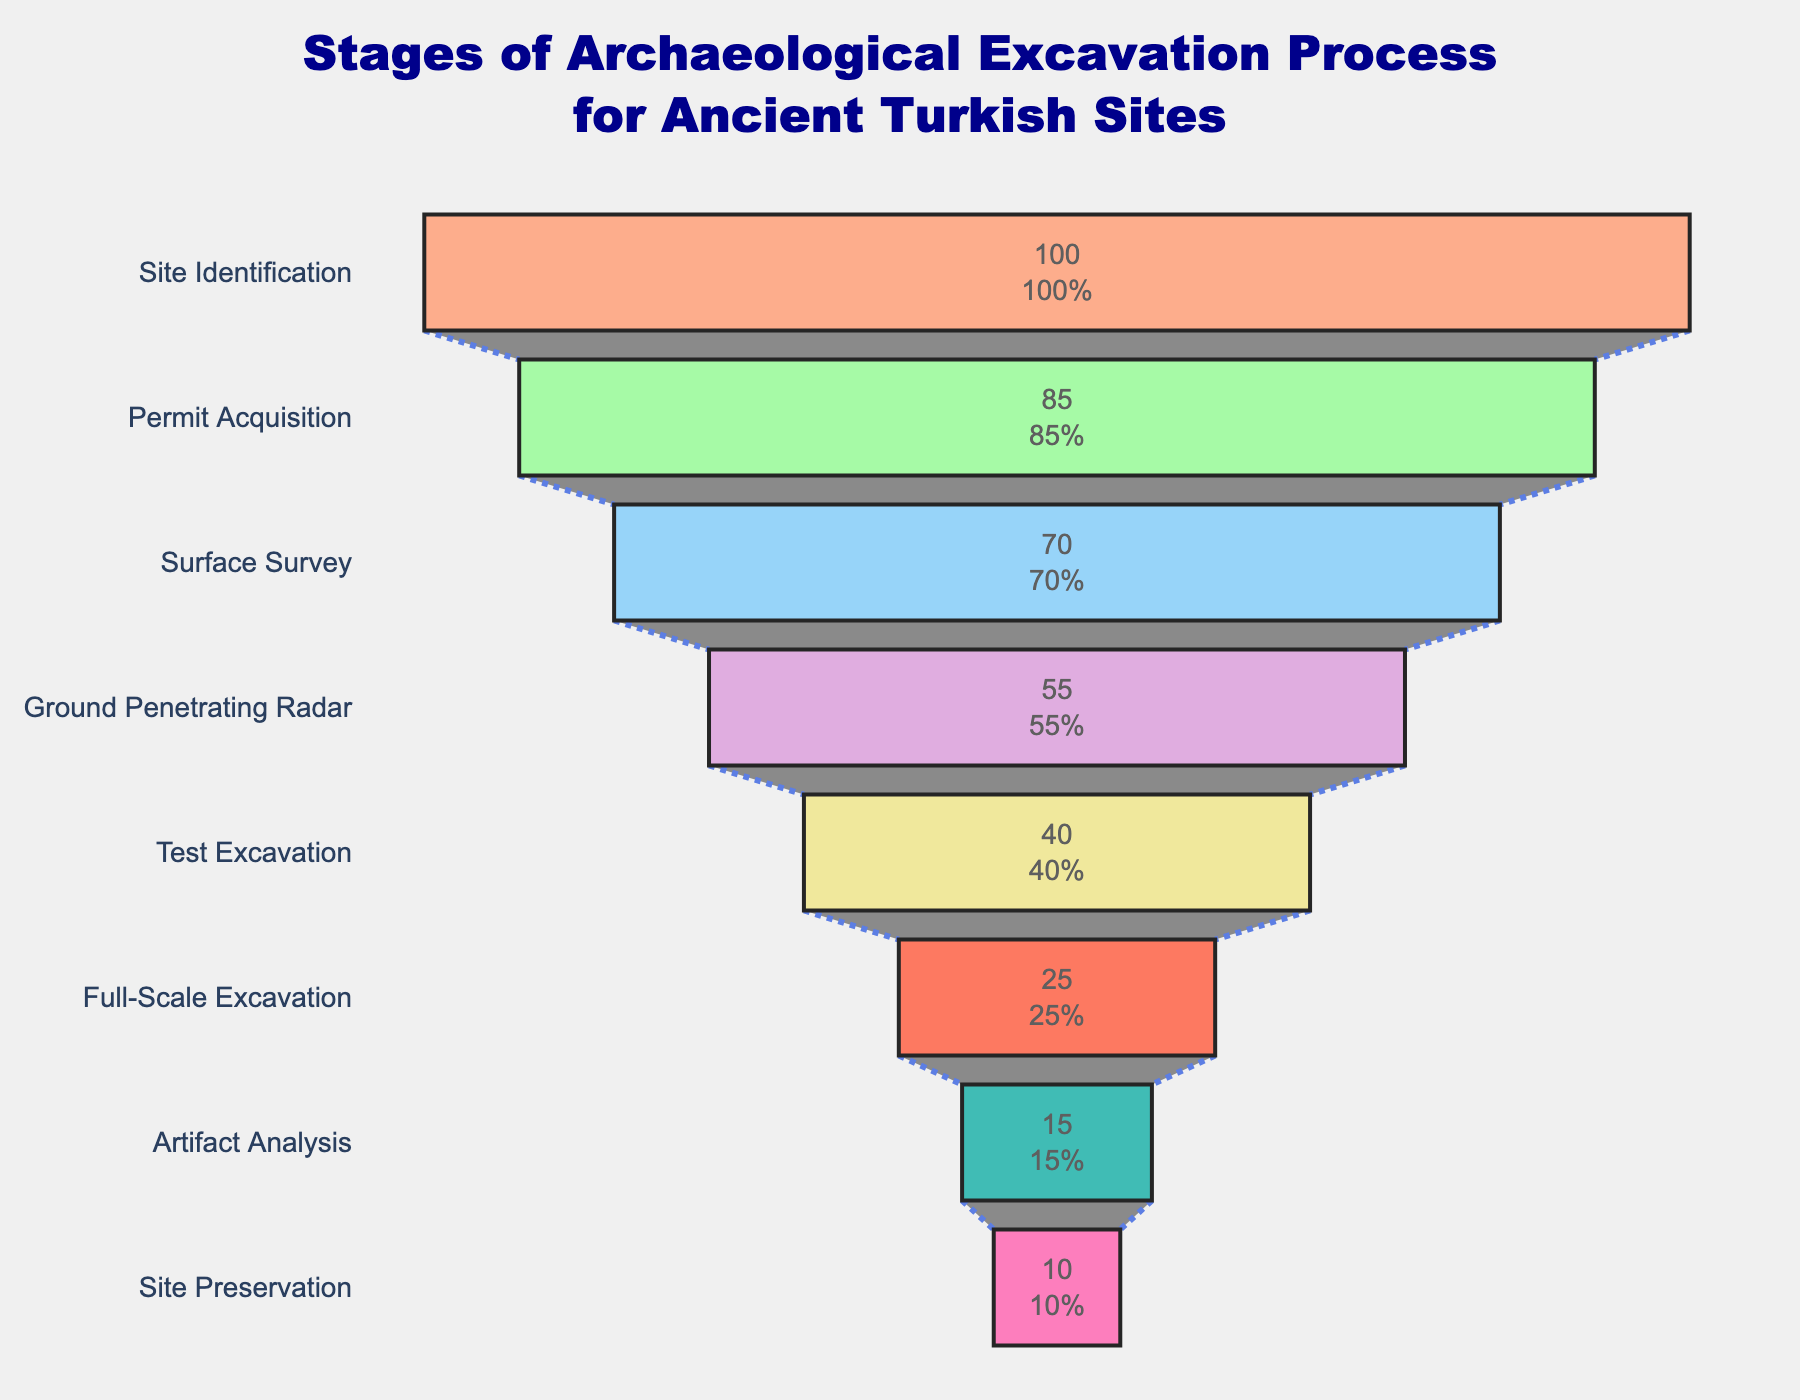What is the title of the figure? The title of the figure is usually prominently placed at the top center of the chart. Here, it states “Stages of Archaeological Excavation Process for Ancient Turkish Sites”.
Answer: Stages of Archaeological Excavation Process for Ancient Turkish Sites Which stage has the lowest percentage in the process? By looking at the percentages listed on the chart, the stage with the lowest percentage is at the bottom of the funnel. The bottom-most stage is “Site Preservation” with 10%.
Answer: Site Preservation How many stages are there in the excavation process? Each separate funnel section represents one stage. By counting these sections, we find there are eight stages.
Answer: 8 What percentage of the process remains after the Test Excavation stage? Observing the funnel chart, the percentage at the Test Excavation stage is 40%. To find what remains after this stage, we check the next stages. The next stage is Full-Scale Excavation, starting at 25%, indicating 25% remains after 40%.
Answer: 25% Which stage involves using Ground Penetrating Radar, and what percentage completes this stage? Find the "Ground Penetrating Radar" label on the funnel, which shows the associated percentage completion. This stage completes at 55%.
Answer: Ground Penetrating Radar, 55% What is the combined percentage of both Permit Acquisition and Surface Survey stages? To find the combined percentage, add the percentages of Permit Acquisition (85%) and Surface Survey (70%). 85% + 70% = 155%.
Answer: 155% How much larger, percentage-wise, is Site Identification compared to Site Preservation? Site Identification stands at 100%, and Site Preservation is at 10%. The difference is calculated as 100% - 10% = 90%.
Answer: 90% What two stages experience the largest percentage drop? By comparing percentages between consecutive stages, the largest drop is between Surface Survey (70%) to Ground Penetrating Radar (55%) with a drop of 15%, and another drop from Full-Scale Excavation (25%) to Artifact Analysis (15%) at 10%. The largest drop is 15%.
Answer: Surface Survey to Ground Penetrating Radar, 15% How does the percentage completion of Artifact Analysis compare to Test Excavation? The chart indicates Test Excavation at 40% and Artifact Analysis at 15%. To compare, subtract 15% from 40% which equals 25%. Test Excavation completion is 25% higher than Artifact Analysis.
Answer: 25% higher 